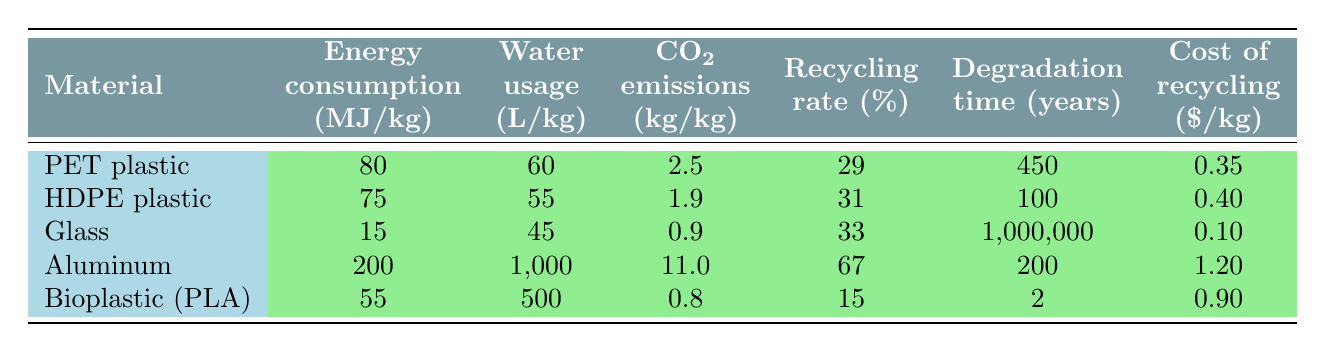What is the energy consumption of glass? The energy consumption for glass is listed in the table under the relevant column, which shows 15 MJ/kg.
Answer: 15 MJ/kg Which material has the highest recycling rate? By examining the recycling rate percentages for all the materials in the table, aluminum has the highest rate at 67%.
Answer: Aluminum What is the total CO2 emissions for HDPE plastic and bioplastic (PLA) combined? To find the total CO2 emissions, add together the CO2 emissions for HDPE plastic (1.9 kg/kg) and bioplastic (PLA) (0.8 kg/kg): 1.9 + 0.8 = 2.7 kg/kg.
Answer: 2.7 kg/kg Is the degradation time for glass greater than that for bioplastic (PLA)? The degradation time for glass is 1,000,000 years and for bioplastic (PLA) it is 2 years; since 1,000,000 is greater than 2, the answer is yes.
Answer: Yes What is the average water usage for PET plastic and HDPE plastic? To find the average, sum the water usage values for both (60 L/kg for PET and 55 L/kg for HDPE) to get 115 L/kg. Then divide by the number of materials (2): 115 / 2 = 57.5 L/kg.
Answer: 57.5 L/kg Which material has the lowest cost of recycling? By checking the costs for recycling in the last column, glass has the lowest cost listed at 0.10 $/kg.
Answer: Glass What is the difference in energy consumption between aluminum and bioplastic (PLA)? First, the energy consumption for aluminum is 200 MJ/kg and for bioplastic (PLA) is 55 MJ/kg. Subtract the latter from the former: 200 - 55 = 145 MJ/kg.
Answer: 145 MJ/kg Is the water usage for aluminum less than for glass? Comparing the water usage values, aluminum uses 1000 L/kg while glass uses 45 L/kg; 1000 is greater than 45, so the answer is no.
Answer: No What is the degradation time for aluminum compared to HDPE plastic? The degradation time for aluminum is 200 years, while for HDPE plastic it is 100 years. Since 200 is greater than 100, aluminum has a longer degradation time.
Answer: Yes 